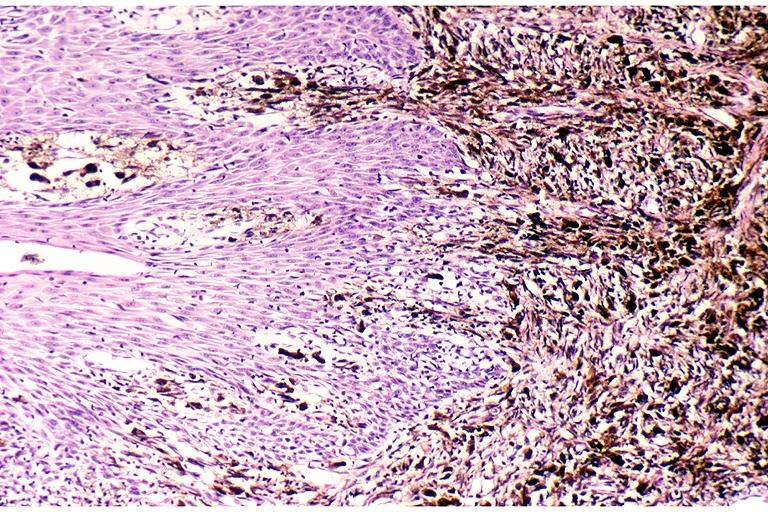s oral present?
Answer the question using a single word or phrase. Yes 